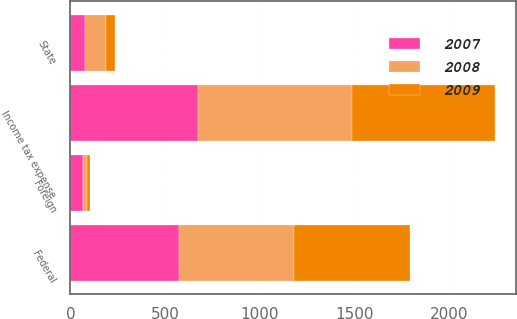Convert chart. <chart><loc_0><loc_0><loc_500><loc_500><stacked_bar_chart><ecel><fcel>Federal<fcel>State<fcel>Foreign<fcel>Income tax expense<nl><fcel>2007<fcel>573<fcel>78<fcel>66<fcel>674<nl><fcel>2008<fcel>609<fcel>110<fcel>22<fcel>815<nl><fcel>2009<fcel>609<fcel>45<fcel>16<fcel>752<nl></chart> 